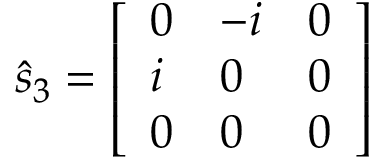<formula> <loc_0><loc_0><loc_500><loc_500>{ \hat { s } } _ { 3 } = { \left [ \begin{array} { l l l } { 0 } & { - i } & { 0 } \\ { i } & { 0 } & { 0 } \\ { 0 } & { 0 } & { 0 } \end{array} \right ] }</formula> 